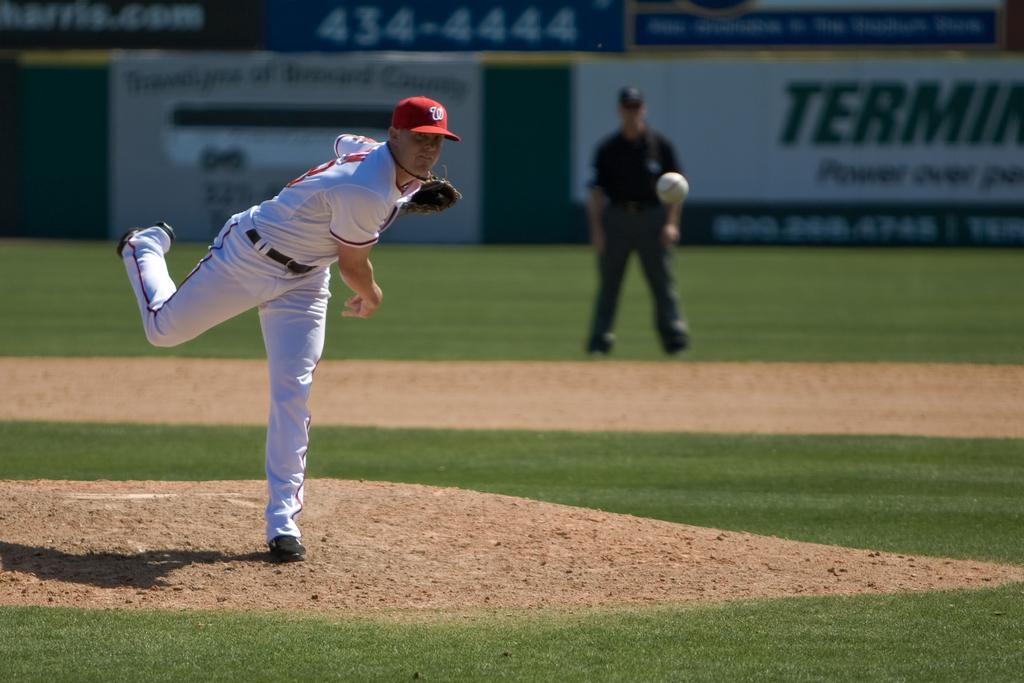<image>
Render a clear and concise summary of the photo. A baseball player in a white uniform pitches the ball with a banner in the backround displaying phone number 434-4444. 